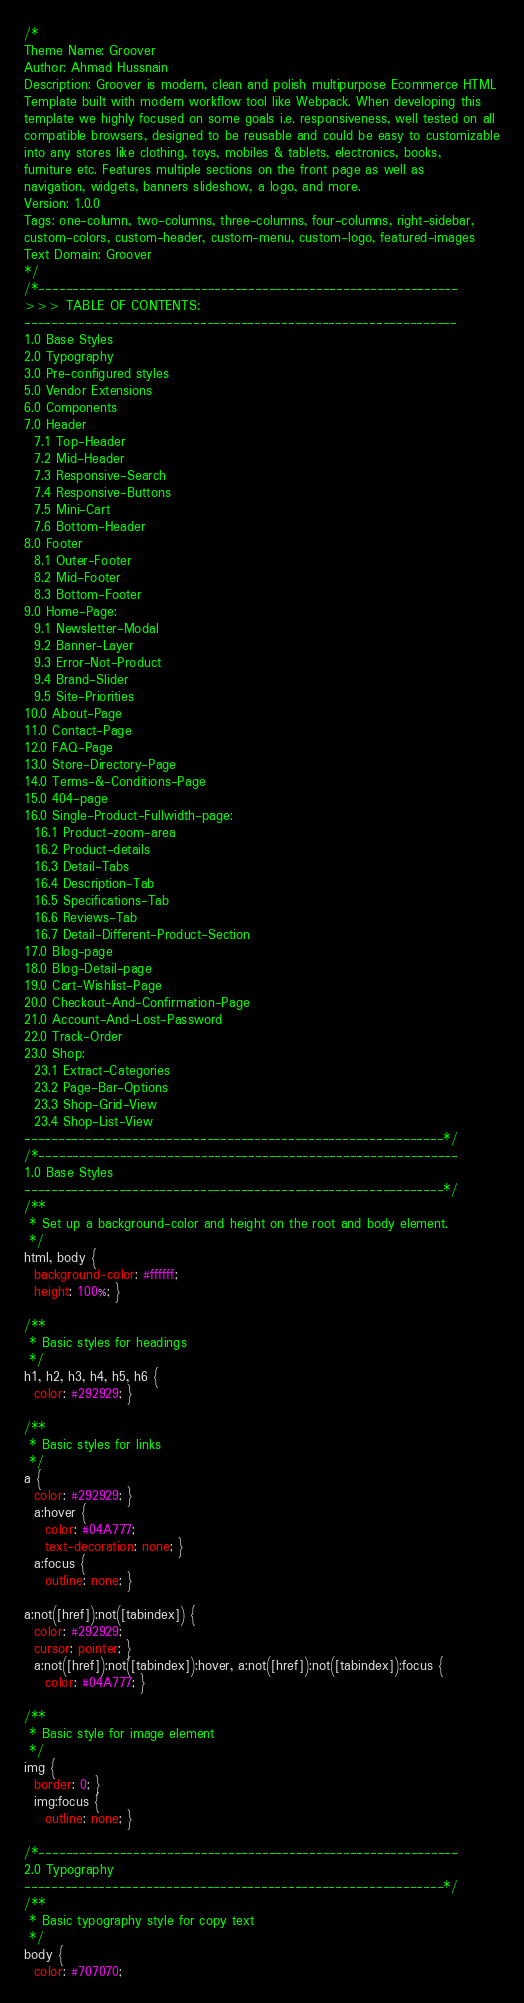<code> <loc_0><loc_0><loc_500><loc_500><_CSS_>/*
Theme Name: Groover
Author: Ahmad Hussnain
Description: Groover is modern, clean and polish multipurpose Ecommerce HTML
Template built with modern workflow tool like Webpack. When developing this
template we highly focused on some goals i.e. responsiveness, well tested on all
compatible browsers, designed to be reusable and could be easy to customizable
into any stores like clothing, toys, mobiles & tablets, electronics, books,
furniture etc. Features multiple sections on the front page as well as
navigation, widgets, banners slideshow, a logo, and more.
Version: 1.0.0
Tags: one-column, two-columns, three-columns, four-columns, right-sidebar,
custom-colors, custom-header, custom-menu, custom-logo, featured-images
Text Domain: Groover
*/
/*--------------------------------------------------------------
>>> TABLE OF CONTENTS:
----------------------------------------------------------------
1.0 Base Styles
2.0 Typography
3.0 Pre-configured styles
5.0 Vendor Extensions
6.0 Components
7.0 Header
  7.1 Top-Header
  7.2 Mid-Header
  7.3 Responsive-Search
  7.4 Responsive-Buttons
  7.5 Mini-Cart
  7.6 Bottom-Header
8.0 Footer
  8.1 Outer-Footer
  8.2 Mid-Footer
  8.3 Bottom-Footer
9.0 Home-Page:
  9.1 Newsletter-Modal
  9.2 Banner-Layer
  9.3 Error-Not-Product
  9.4 Brand-Slider
  9.5 Site-Priorities
10.0 About-Page
11.0 Contact-Page
12.0 FAQ-Page
13.0 Store-Directory-Page
14.0 Terms-&-Conditions-Page
15.0 404-page
16.0 Single-Product-Fullwidth-page:
  16.1 Product-zoom-area
  16.2 Product-details
  16.3 Detail-Tabs
  16.4 Description-Tab
  16.5 Specifications-Tab
  16.6 Reviews-Tab
  16.7 Detail-Different-Product-Section
17.0 Blog-page
18.0 Blog-Detail-page
19.0 Cart-Wishlist-Page
20.0 Checkout-And-Confirmation-Page
21.0 Account-And-Lost-Password
22.0 Track-Order
23.0 Shop:
  23.1 Extract-Categories
  23.2 Page-Bar-Options
  23.3 Shop-Grid-View
  23.4 Shop-List-View
--------------------------------------------------------------*/
/*--------------------------------------------------------------
1.0 Base Styles
--------------------------------------------------------------*/
/**
 * Set up a background-color and height on the root and body element.
 */
html, body {
  background-color: #ffffff;
  height: 100%; }

/**
 * Basic styles for headings
 */
h1, h2, h3, h4, h5, h6 {
  color: #292929; }

/**
 * Basic styles for links
 */
a {
  color: #292929; }
  a:hover {
    color: #04A777;
    text-decoration: none; }
  a:focus {
    outline: none; }

a:not([href]):not([tabindex]) {
  color: #292929;
  cursor: pointer; }
  a:not([href]):not([tabindex]):hover, a:not([href]):not([tabindex]):focus {
    color: #04A777; }

/**
 * Basic style for image element
 */
img {
  border: 0; }
  img:focus {
    outline: none; }

/*--------------------------------------------------------------
2.0 Typography
--------------------------------------------------------------*/
/**
 * Basic typography style for copy text
 */
body {
  color: #707070;</code> 